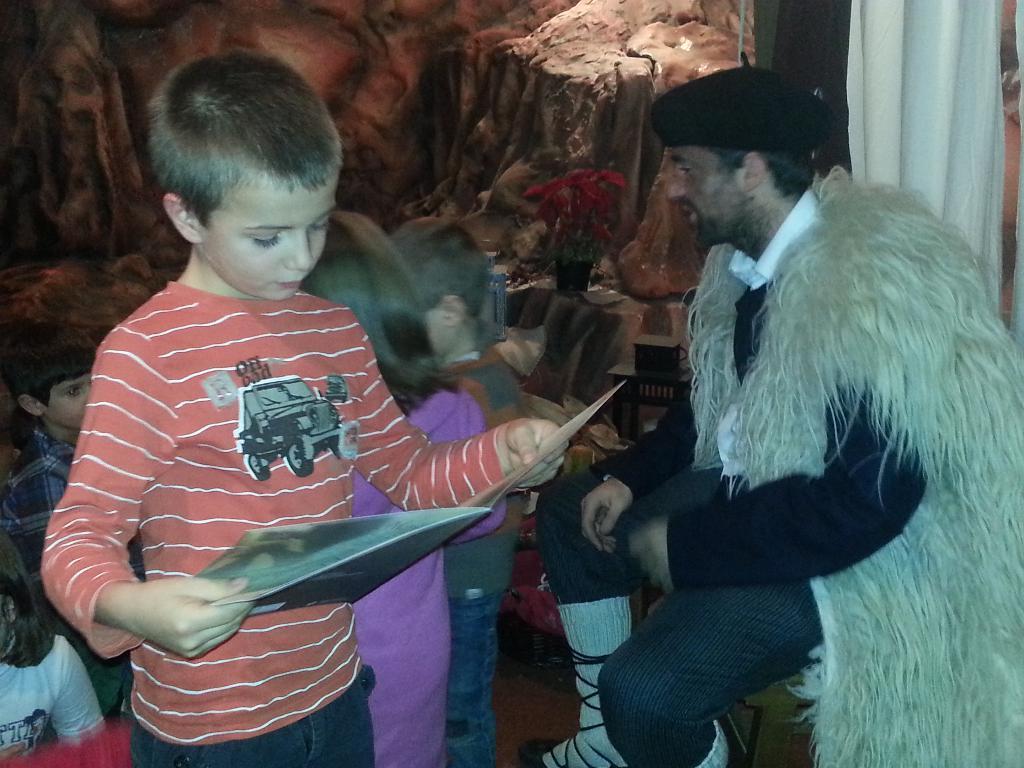Could you give a brief overview of what you see in this image? In this image I can see the group of people with different color dresses. I can see one person is holding the file. In the back there is a curtain and the rack. 